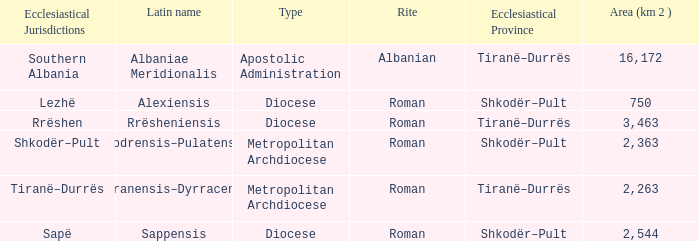What is Type for Rite Albanian? Apostolic Administration. 